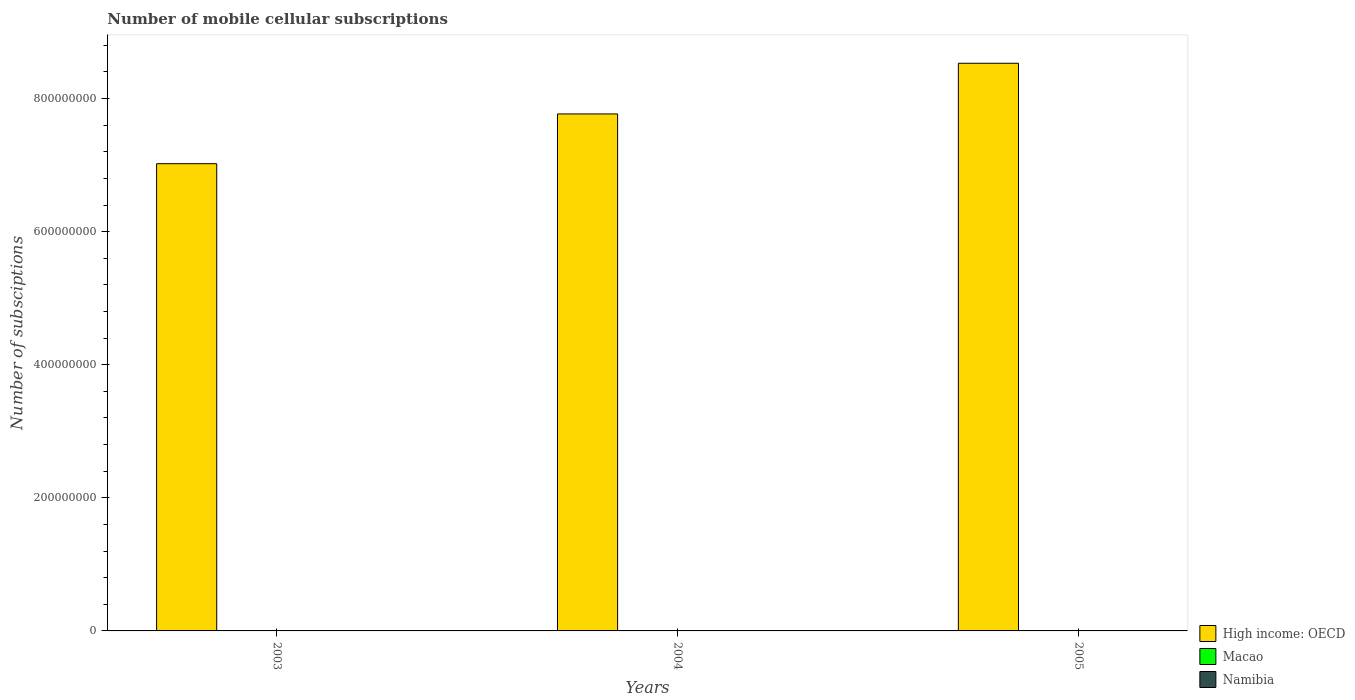How many groups of bars are there?
Your response must be concise. 3. Are the number of bars per tick equal to the number of legend labels?
Make the answer very short. Yes. How many bars are there on the 3rd tick from the left?
Provide a short and direct response. 3. How many bars are there on the 1st tick from the right?
Ensure brevity in your answer.  3. What is the label of the 1st group of bars from the left?
Your answer should be very brief. 2003. What is the number of mobile cellular subscriptions in Namibia in 2005?
Your answer should be compact. 4.49e+05. Across all years, what is the maximum number of mobile cellular subscriptions in High income: OECD?
Provide a succinct answer. 8.53e+08. Across all years, what is the minimum number of mobile cellular subscriptions in High income: OECD?
Keep it short and to the point. 7.02e+08. In which year was the number of mobile cellular subscriptions in High income: OECD maximum?
Keep it short and to the point. 2005. In which year was the number of mobile cellular subscriptions in High income: OECD minimum?
Offer a very short reply. 2003. What is the total number of mobile cellular subscriptions in Namibia in the graph?
Provide a succinct answer. 9.59e+05. What is the difference between the number of mobile cellular subscriptions in Macao in 2003 and that in 2005?
Keep it short and to the point. -1.69e+05. What is the difference between the number of mobile cellular subscriptions in High income: OECD in 2003 and the number of mobile cellular subscriptions in Namibia in 2004?
Offer a very short reply. 7.02e+08. What is the average number of mobile cellular subscriptions in High income: OECD per year?
Offer a very short reply. 7.77e+08. In the year 2003, what is the difference between the number of mobile cellular subscriptions in Macao and number of mobile cellular subscriptions in High income: OECD?
Keep it short and to the point. -7.02e+08. In how many years, is the number of mobile cellular subscriptions in Macao greater than 600000000?
Your answer should be very brief. 0. What is the ratio of the number of mobile cellular subscriptions in High income: OECD in 2003 to that in 2005?
Your answer should be very brief. 0.82. Is the difference between the number of mobile cellular subscriptions in Macao in 2003 and 2004 greater than the difference between the number of mobile cellular subscriptions in High income: OECD in 2003 and 2004?
Your answer should be very brief. Yes. What is the difference between the highest and the second highest number of mobile cellular subscriptions in Macao?
Give a very brief answer. 1.00e+05. What is the difference between the highest and the lowest number of mobile cellular subscriptions in Macao?
Make the answer very short. 1.69e+05. Is the sum of the number of mobile cellular subscriptions in Macao in 2003 and 2004 greater than the maximum number of mobile cellular subscriptions in Namibia across all years?
Make the answer very short. Yes. What does the 1st bar from the left in 2004 represents?
Give a very brief answer. High income: OECD. What does the 2nd bar from the right in 2005 represents?
Give a very brief answer. Macao. How many bars are there?
Ensure brevity in your answer.  9. How many years are there in the graph?
Provide a succinct answer. 3. What is the difference between two consecutive major ticks on the Y-axis?
Your response must be concise. 2.00e+08. Where does the legend appear in the graph?
Provide a succinct answer. Bottom right. How many legend labels are there?
Offer a very short reply. 3. What is the title of the graph?
Offer a terse response. Number of mobile cellular subscriptions. Does "Eritrea" appear as one of the legend labels in the graph?
Provide a succinct answer. No. What is the label or title of the X-axis?
Your answer should be very brief. Years. What is the label or title of the Y-axis?
Provide a short and direct response. Number of subsciptions. What is the Number of subsciptions of High income: OECD in 2003?
Provide a short and direct response. 7.02e+08. What is the Number of subsciptions of Macao in 2003?
Offer a very short reply. 3.64e+05. What is the Number of subsciptions of Namibia in 2003?
Offer a terse response. 2.24e+05. What is the Number of subsciptions in High income: OECD in 2004?
Keep it short and to the point. 7.77e+08. What is the Number of subsciptions of Macao in 2004?
Keep it short and to the point. 4.32e+05. What is the Number of subsciptions of Namibia in 2004?
Your response must be concise. 2.86e+05. What is the Number of subsciptions of High income: OECD in 2005?
Keep it short and to the point. 8.53e+08. What is the Number of subsciptions of Macao in 2005?
Your answer should be very brief. 5.33e+05. What is the Number of subsciptions of Namibia in 2005?
Offer a terse response. 4.49e+05. Across all years, what is the maximum Number of subsciptions in High income: OECD?
Make the answer very short. 8.53e+08. Across all years, what is the maximum Number of subsciptions in Macao?
Offer a very short reply. 5.33e+05. Across all years, what is the maximum Number of subsciptions of Namibia?
Provide a short and direct response. 4.49e+05. Across all years, what is the minimum Number of subsciptions of High income: OECD?
Ensure brevity in your answer.  7.02e+08. Across all years, what is the minimum Number of subsciptions in Macao?
Provide a short and direct response. 3.64e+05. Across all years, what is the minimum Number of subsciptions of Namibia?
Give a very brief answer. 2.24e+05. What is the total Number of subsciptions of High income: OECD in the graph?
Offer a very short reply. 2.33e+09. What is the total Number of subsciptions of Macao in the graph?
Offer a terse response. 1.33e+06. What is the total Number of subsciptions in Namibia in the graph?
Your answer should be compact. 9.59e+05. What is the difference between the Number of subsciptions in High income: OECD in 2003 and that in 2004?
Make the answer very short. -7.48e+07. What is the difference between the Number of subsciptions in Macao in 2003 and that in 2004?
Keep it short and to the point. -6.84e+04. What is the difference between the Number of subsciptions in Namibia in 2003 and that in 2004?
Your answer should be very brief. -6.24e+04. What is the difference between the Number of subsciptions of High income: OECD in 2003 and that in 2005?
Ensure brevity in your answer.  -1.51e+08. What is the difference between the Number of subsciptions of Macao in 2003 and that in 2005?
Your answer should be compact. -1.69e+05. What is the difference between the Number of subsciptions of Namibia in 2003 and that in 2005?
Give a very brief answer. -2.25e+05. What is the difference between the Number of subsciptions of High income: OECD in 2004 and that in 2005?
Offer a very short reply. -7.62e+07. What is the difference between the Number of subsciptions of Macao in 2004 and that in 2005?
Provide a short and direct response. -1.00e+05. What is the difference between the Number of subsciptions of Namibia in 2004 and that in 2005?
Offer a very short reply. -1.63e+05. What is the difference between the Number of subsciptions in High income: OECD in 2003 and the Number of subsciptions in Macao in 2004?
Your response must be concise. 7.02e+08. What is the difference between the Number of subsciptions of High income: OECD in 2003 and the Number of subsciptions of Namibia in 2004?
Make the answer very short. 7.02e+08. What is the difference between the Number of subsciptions in Macao in 2003 and the Number of subsciptions in Namibia in 2004?
Keep it short and to the point. 7.79e+04. What is the difference between the Number of subsciptions in High income: OECD in 2003 and the Number of subsciptions in Macao in 2005?
Your response must be concise. 7.02e+08. What is the difference between the Number of subsciptions in High income: OECD in 2003 and the Number of subsciptions in Namibia in 2005?
Make the answer very short. 7.02e+08. What is the difference between the Number of subsciptions of Macao in 2003 and the Number of subsciptions of Namibia in 2005?
Provide a succinct answer. -8.48e+04. What is the difference between the Number of subsciptions of High income: OECD in 2004 and the Number of subsciptions of Macao in 2005?
Provide a succinct answer. 7.76e+08. What is the difference between the Number of subsciptions of High income: OECD in 2004 and the Number of subsciptions of Namibia in 2005?
Your response must be concise. 7.77e+08. What is the difference between the Number of subsciptions in Macao in 2004 and the Number of subsciptions in Namibia in 2005?
Your answer should be very brief. -1.64e+04. What is the average Number of subsciptions in High income: OECD per year?
Ensure brevity in your answer.  7.77e+08. What is the average Number of subsciptions in Macao per year?
Your response must be concise. 4.43e+05. What is the average Number of subsciptions in Namibia per year?
Offer a very short reply. 3.20e+05. In the year 2003, what is the difference between the Number of subsciptions of High income: OECD and Number of subsciptions of Macao?
Offer a very short reply. 7.02e+08. In the year 2003, what is the difference between the Number of subsciptions in High income: OECD and Number of subsciptions in Namibia?
Your answer should be very brief. 7.02e+08. In the year 2003, what is the difference between the Number of subsciptions in Macao and Number of subsciptions in Namibia?
Your answer should be very brief. 1.40e+05. In the year 2004, what is the difference between the Number of subsciptions of High income: OECD and Number of subsciptions of Macao?
Your response must be concise. 7.77e+08. In the year 2004, what is the difference between the Number of subsciptions of High income: OECD and Number of subsciptions of Namibia?
Ensure brevity in your answer.  7.77e+08. In the year 2004, what is the difference between the Number of subsciptions of Macao and Number of subsciptions of Namibia?
Provide a succinct answer. 1.46e+05. In the year 2005, what is the difference between the Number of subsciptions of High income: OECD and Number of subsciptions of Macao?
Provide a succinct answer. 8.53e+08. In the year 2005, what is the difference between the Number of subsciptions in High income: OECD and Number of subsciptions in Namibia?
Your answer should be very brief. 8.53e+08. In the year 2005, what is the difference between the Number of subsciptions of Macao and Number of subsciptions of Namibia?
Ensure brevity in your answer.  8.39e+04. What is the ratio of the Number of subsciptions of High income: OECD in 2003 to that in 2004?
Provide a succinct answer. 0.9. What is the ratio of the Number of subsciptions of Macao in 2003 to that in 2004?
Ensure brevity in your answer.  0.84. What is the ratio of the Number of subsciptions in Namibia in 2003 to that in 2004?
Give a very brief answer. 0.78. What is the ratio of the Number of subsciptions in High income: OECD in 2003 to that in 2005?
Provide a succinct answer. 0.82. What is the ratio of the Number of subsciptions of Macao in 2003 to that in 2005?
Give a very brief answer. 0.68. What is the ratio of the Number of subsciptions of Namibia in 2003 to that in 2005?
Give a very brief answer. 0.5. What is the ratio of the Number of subsciptions in High income: OECD in 2004 to that in 2005?
Your answer should be compact. 0.91. What is the ratio of the Number of subsciptions in Macao in 2004 to that in 2005?
Keep it short and to the point. 0.81. What is the ratio of the Number of subsciptions in Namibia in 2004 to that in 2005?
Ensure brevity in your answer.  0.64. What is the difference between the highest and the second highest Number of subsciptions in High income: OECD?
Give a very brief answer. 7.62e+07. What is the difference between the highest and the second highest Number of subsciptions of Macao?
Your response must be concise. 1.00e+05. What is the difference between the highest and the second highest Number of subsciptions in Namibia?
Ensure brevity in your answer.  1.63e+05. What is the difference between the highest and the lowest Number of subsciptions of High income: OECD?
Provide a short and direct response. 1.51e+08. What is the difference between the highest and the lowest Number of subsciptions in Macao?
Offer a very short reply. 1.69e+05. What is the difference between the highest and the lowest Number of subsciptions in Namibia?
Your answer should be very brief. 2.25e+05. 